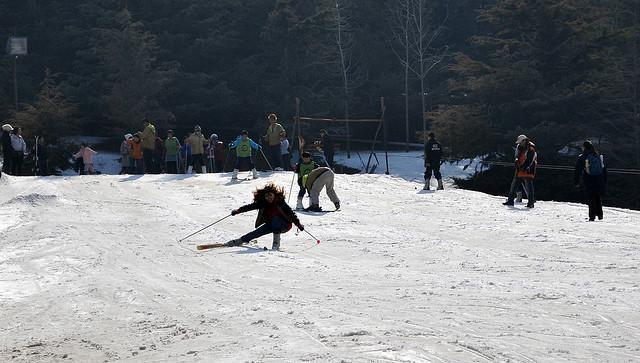How many people can you see?
Give a very brief answer. 2. 